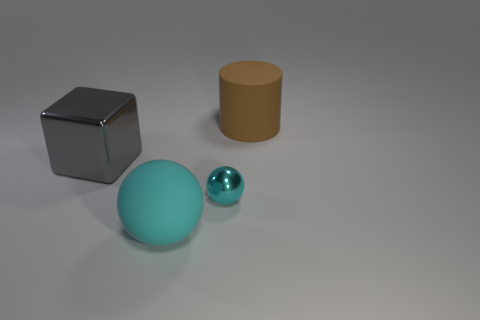Is there any other thing that is the same size as the cyan metal thing?
Ensure brevity in your answer.  No. What is the shape of the big matte object that is the same color as the small thing?
Ensure brevity in your answer.  Sphere. Is there another purple sphere made of the same material as the tiny ball?
Your response must be concise. No. Are the block and the cyan ball in front of the small cyan thing made of the same material?
Your answer should be very brief. No. There is a rubber cylinder that is the same size as the gray thing; what color is it?
Your answer should be compact. Brown. What is the size of the matte thing that is to the left of the big matte object that is behind the tiny cyan ball?
Provide a short and direct response. Large. There is a big rubber sphere; is its color the same as the large rubber thing right of the large ball?
Provide a short and direct response. No. Is the number of spheres right of the cyan rubber object less than the number of small brown metal blocks?
Give a very brief answer. No. What number of other objects are the same size as the cyan metallic ball?
Your answer should be compact. 0. There is a large matte thing left of the large brown rubber cylinder; is its shape the same as the tiny cyan object?
Your response must be concise. Yes. 